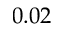Convert formula to latex. <formula><loc_0><loc_0><loc_500><loc_500>0 . 0 2</formula> 